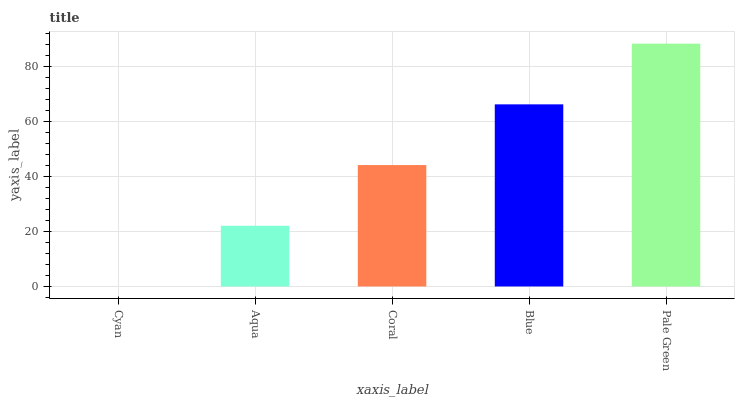Is Cyan the minimum?
Answer yes or no. Yes. Is Pale Green the maximum?
Answer yes or no. Yes. Is Aqua the minimum?
Answer yes or no. No. Is Aqua the maximum?
Answer yes or no. No. Is Aqua greater than Cyan?
Answer yes or no. Yes. Is Cyan less than Aqua?
Answer yes or no. Yes. Is Cyan greater than Aqua?
Answer yes or no. No. Is Aqua less than Cyan?
Answer yes or no. No. Is Coral the high median?
Answer yes or no. Yes. Is Coral the low median?
Answer yes or no. Yes. Is Pale Green the high median?
Answer yes or no. No. Is Blue the low median?
Answer yes or no. No. 